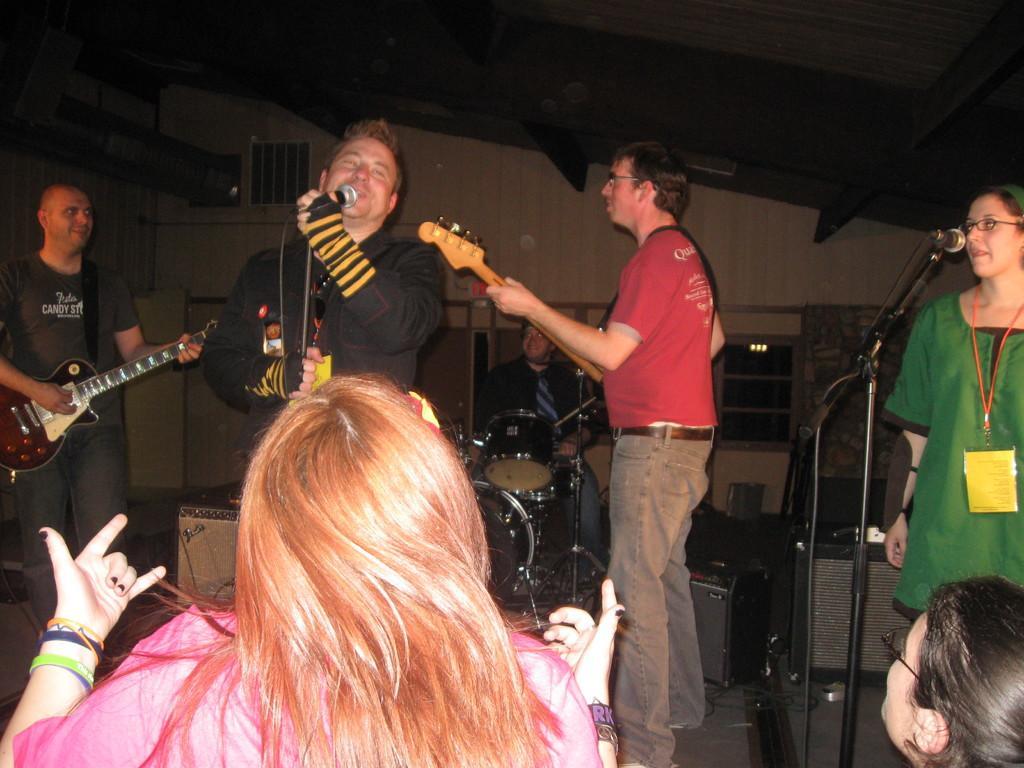Could you give a brief overview of what you see in this image? I can see a man standing and singing a song using a mike. At the left corner of the image I can see a man standing and playing guitar. At the right side of the image another man is standing and playing guitar. I can see a women at the right corner of the image is standing and singing a song. At background I can see a man sitting and playing drums. This woman is standing and watching the performance. 